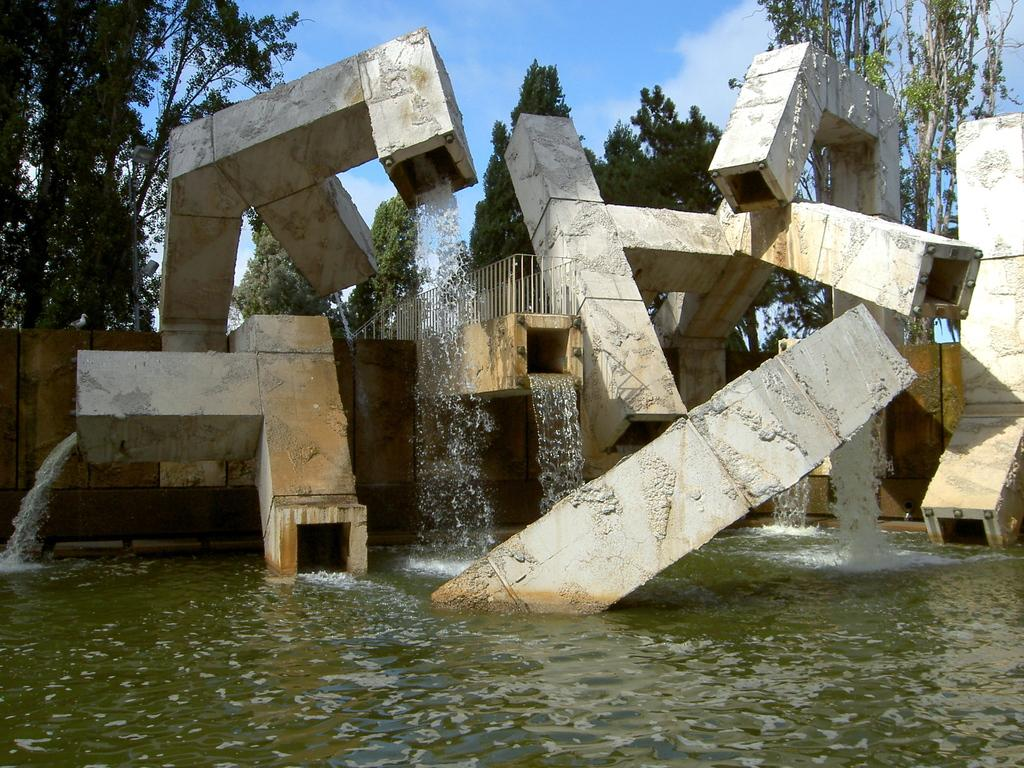What type of structures are present in the image? There are concrete pillars in the image. What natural element can be seen in the image? There is water visible in the image. What type of vegetation is in the background of the image? There are trees in the background of the image. What type of harmony is being played by the secretary in the image? There is no secretary or any musical instrument present in the image, so it is not possible to determine if any harmony is being played. 